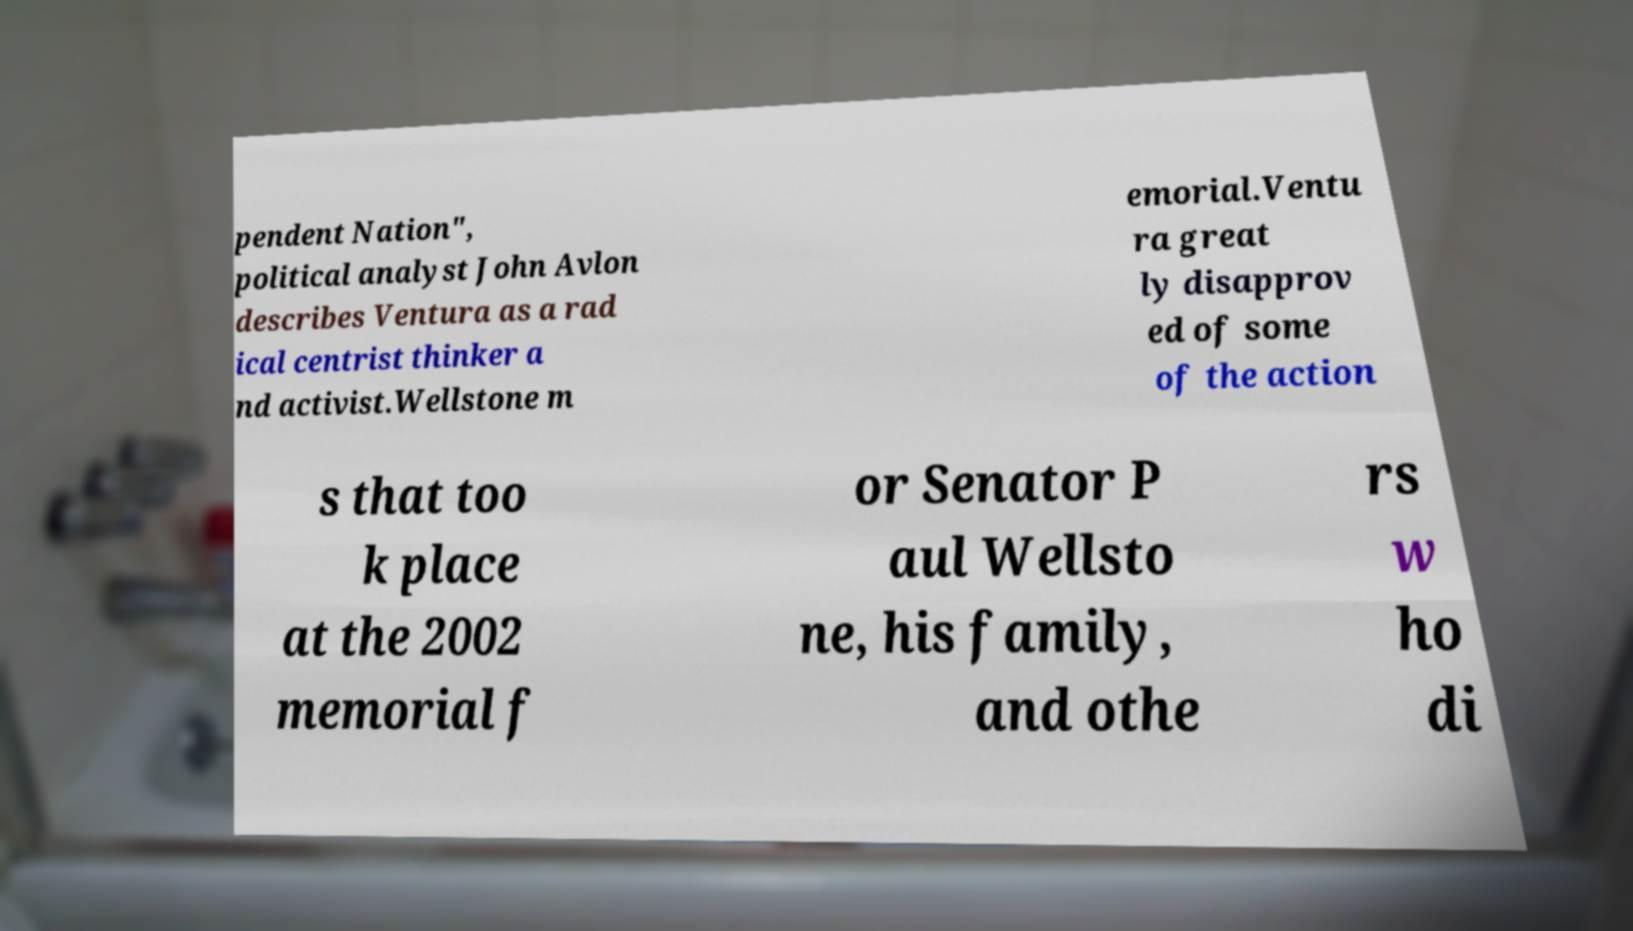Could you extract and type out the text from this image? pendent Nation", political analyst John Avlon describes Ventura as a rad ical centrist thinker a nd activist.Wellstone m emorial.Ventu ra great ly disapprov ed of some of the action s that too k place at the 2002 memorial f or Senator P aul Wellsto ne, his family, and othe rs w ho di 